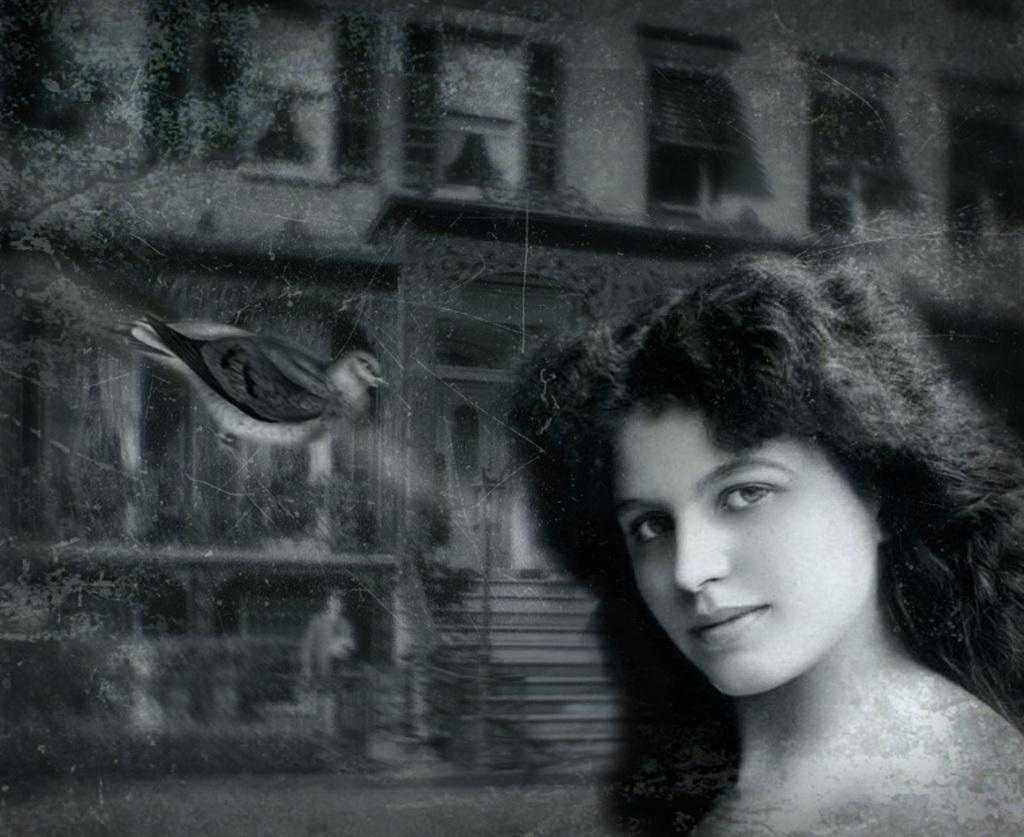Who is the main subject in the image? There is a girl in the image. What is the girl doing in the image? The girl is giving a pose into the camera and smiling. Is there anything else in the image besides the girl? Yes, there is a bird flying in the air and an old building in the image. What is the grandfather doing in the image? There is no grandfather present in the image. What season is it in the image? The provided facts do not mention the season, so it cannot be determined from the image. 